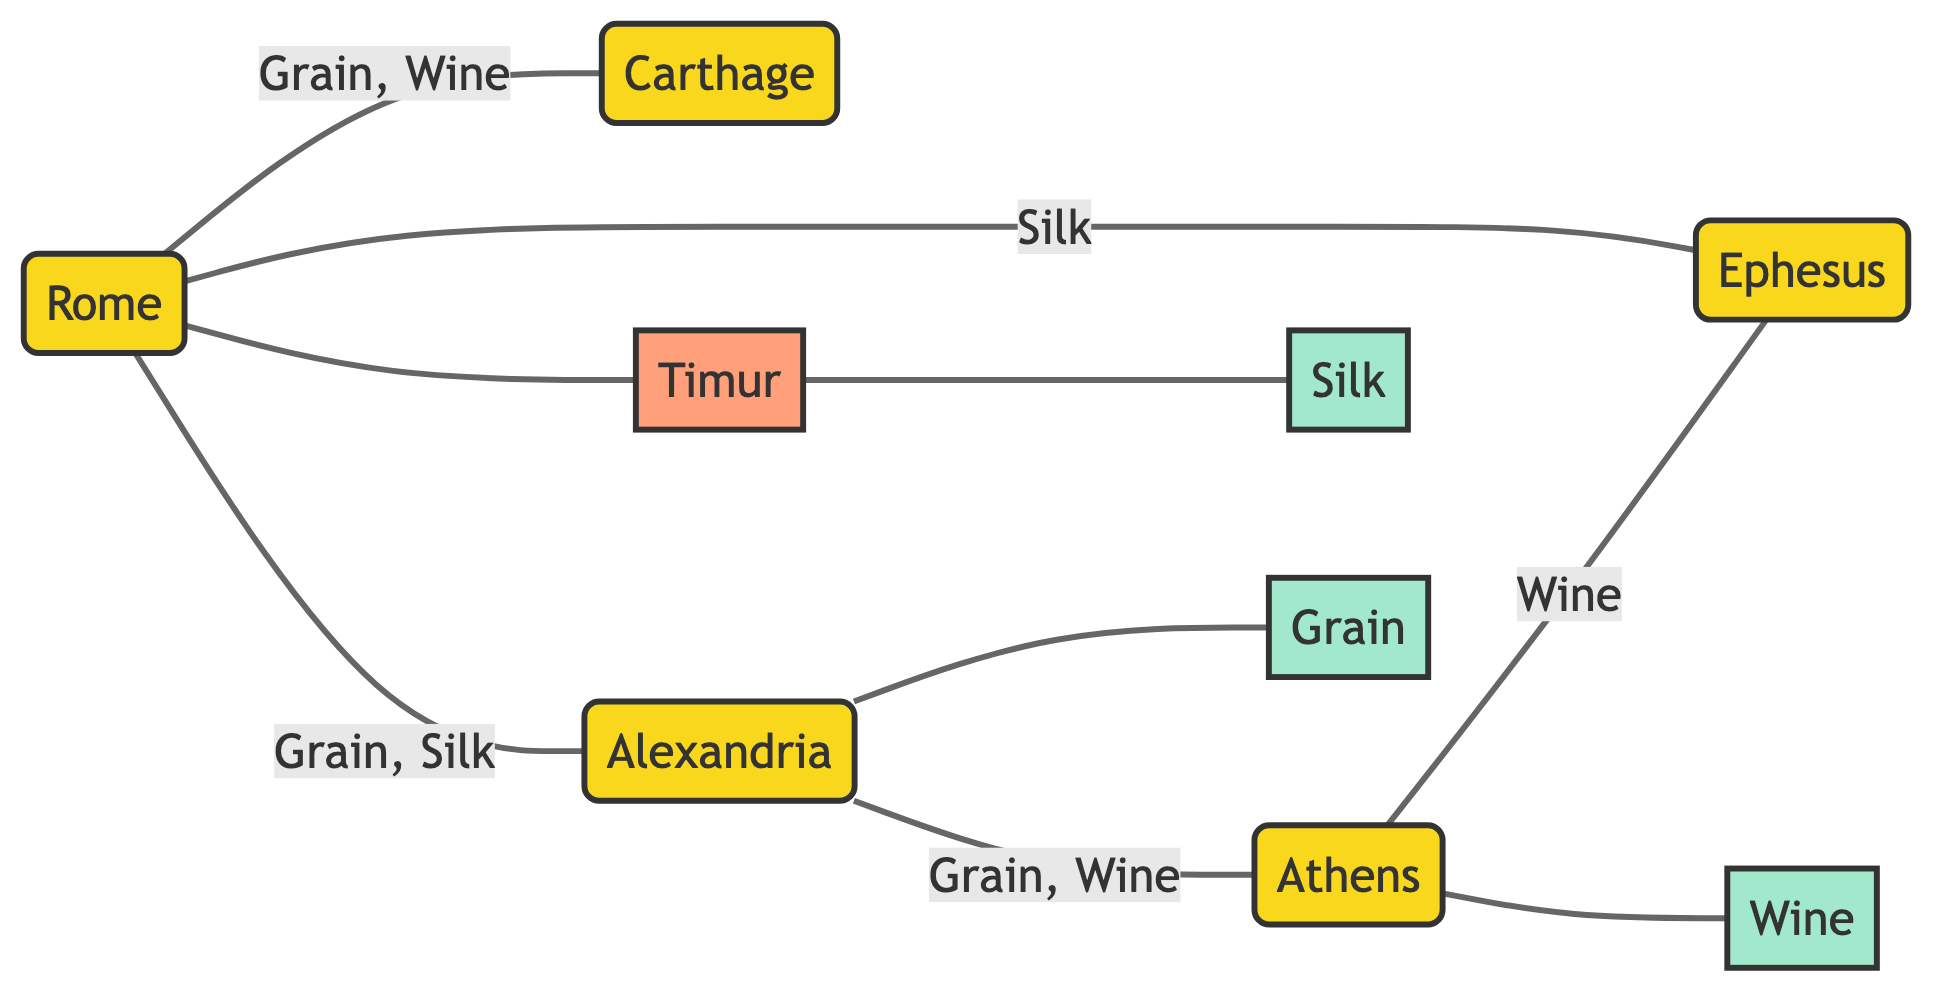What is the total number of cities in the diagram? The diagram lists five cities: Rome, Carthage, Alexandria, Athens, and Ephesus. Counting these nodes give a total of five.
Answer: 5 Which two commodities are traded between Rome and Carthage? The edge connecting Rome and Carthage specifies that grain and wine are the commodities exchanged between these two cities.
Answer: Grain, Wine Who is the historical figure related to trading in the diagram? The diagram identifies Timur as the historical figure involved in trade, specifically as a silk trader connected to the Mediterranean ports.
Answer: Timur What is the trade route connecting Alexandria and Athens primarily known for? The edge between Alexandria and Athens shows that the trade route is significant for the exchange of grain and wine, hence it represents goods and ideas.
Answer: Grain, Wine Which city is the origin of grain according to the diagram? The diagram attributes grain specifically to its origin in Egypt, as noted in the attributes of the commodity node Grain.
Answer: Egypt Which commodity flows from Rome to Ephesus? The edge between Rome and Ephesus indicates that silk is the specific commodity traded along this route, highlighting the luxury trade connections.
Answer: Silk What percentage of cities in the diagram are labeled as high importance? There are three cities (Rome, Carthage, and Alexandria) marked as high importance out of five total cities, which makes it 60%.
Answer: 60% Which trade route is described as a conduit for luxury items? The route from Rome to Ephesus is specifically described as the conduit for luxury items, namely silk, emphasizing its significance in the luxury goods trade.
Answer: Silk How many commodities are involved in the trade routes from Rome? There are three commodities involved in the trade routes originating from Rome: grain, wine, and silk. Counting these gives a total of three commodities.
Answer: 3 